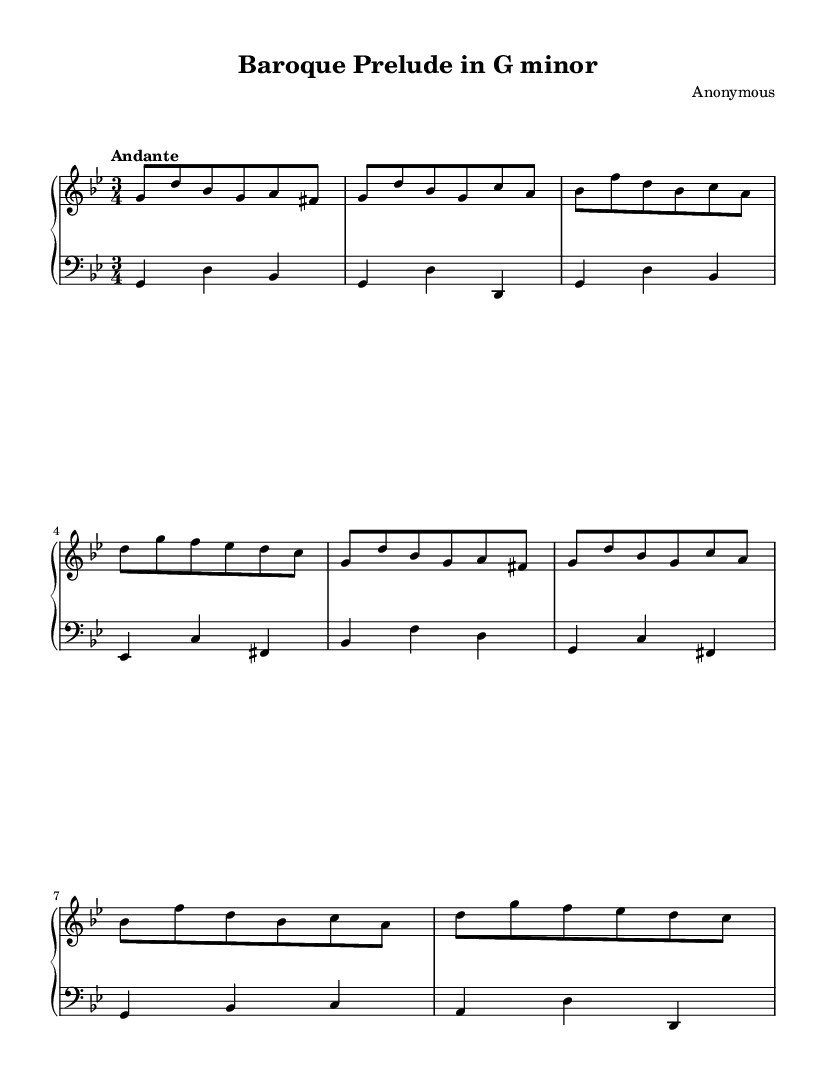What is the key signature of this music? The key signature is G minor, which has two flats (B♭ and E♭). You can determine this from the music notation at the beginning of the staff, where the flats are indicated.
Answer: G minor What is the time signature of the piece? The time signature is 3/4, which indicates three beats per measure, and this can be identified by the two numbers at the beginning of the staff. The top number (3) shows the number of beats, and the bottom number (4) indicates that a quarter note receives one beat.
Answer: 3/4 What is the tempo marking of this piece? The tempo marking is "Andante," which indicates a moderate walking pace. This is found above the staff in the tempo indication written in Italian.
Answer: Andante How many measures are in the piece? There are eight measures in total, which can be counted by identifying the vertical lines (bar lines) dividing the musical staff into sections. Each section denotes a measure.
Answer: 8 What is the structure of the piece, referring to sections? The piece is structured in two equal parts, where the right hand and the left hand have similar musical phrases. This can be inferred by comparing the sequential grouping of the notes and how they are aligned in two halves.
Answer: Two parts What instrument is indicated in the score? The instrument indicated in the score is the harpsichord, which is specified in the section labeled "midiInstrument." This is commonly associated with Baroque music, thus linking it to the style of the piece.
Answer: Harpsichord What dynamics or expressions are indicated in the sheet music? There are no specific dynamics or expression markings indicated in the score. This is typical for many Baroque pieces, as performers often apply their own interpretations regarding dynamics.
Answer: None 